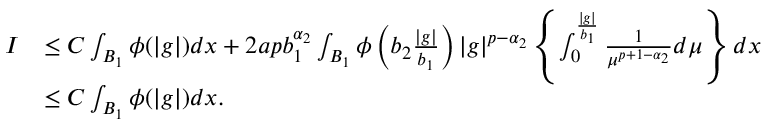<formula> <loc_0><loc_0><loc_500><loc_500>\begin{array} { r l } { I } & { \leq C \int _ { B _ { 1 } } \phi ( | g | ) d x + 2 a p b _ { 1 } ^ { \alpha _ { 2 } } \int _ { B _ { 1 } } \phi \left ( b _ { 2 } \frac { | g | } { b _ { 1 } } \right ) | g | ^ { p - \alpha _ { 2 } } \left \{ \int _ { 0 } ^ { \frac { | g | } { b _ { 1 } } } \frac { 1 } { \mu ^ { p + 1 - \alpha _ { 2 } } } d \mu \right \} d x } \\ & { \leq C \int _ { B _ { 1 } } \phi ( | g | ) d x . } \end{array}</formula> 